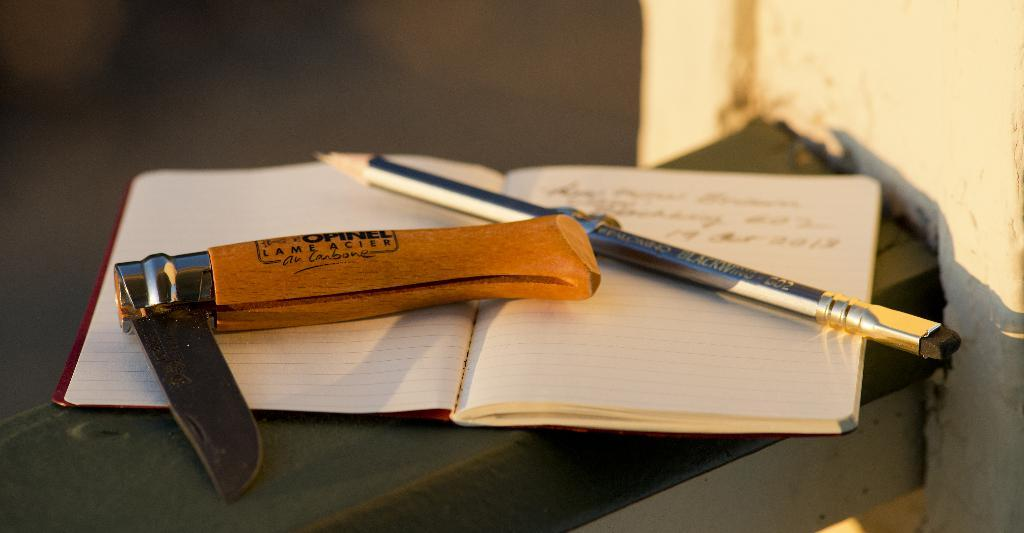What type of writing instrument is present in the image? There is a pencil in the image. What object is typically used for cutting or slicing? There is a knife in the image. What item is commonly used for reading or learning? There is a book in the image. What type of appliance is used for cooking in the image? There is no appliance present in the image. How many ducks can be seen swimming in the image? There are no ducks present in the image. 